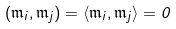<formula> <loc_0><loc_0><loc_500><loc_500>( \mathfrak { m } _ { i } , \mathfrak { m } _ { j } ) = \langle \mathfrak { m } _ { i } , \mathfrak { m } _ { j } \rangle = 0</formula> 